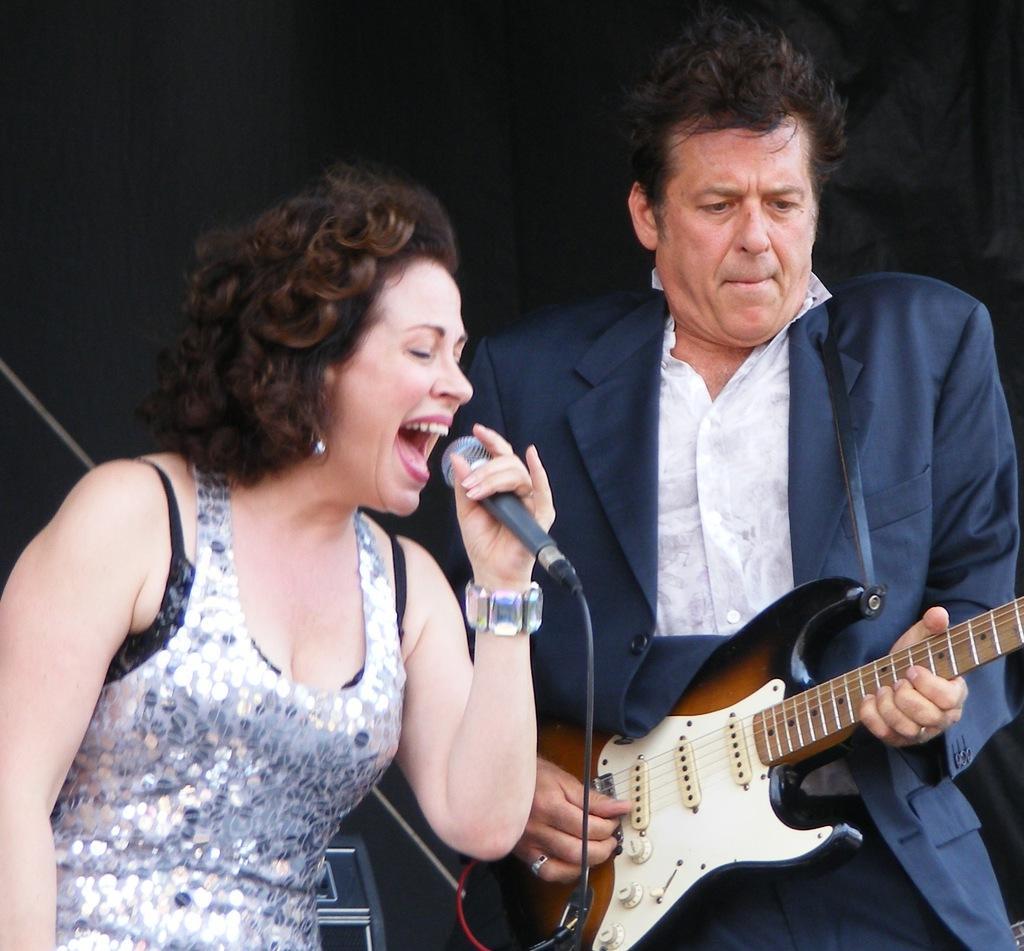Please provide a concise description of this image. Here we can see two people one man and a woman standing, the man is holding a guitar and playing the guitar and the woman is having microphone in her hand and singing 